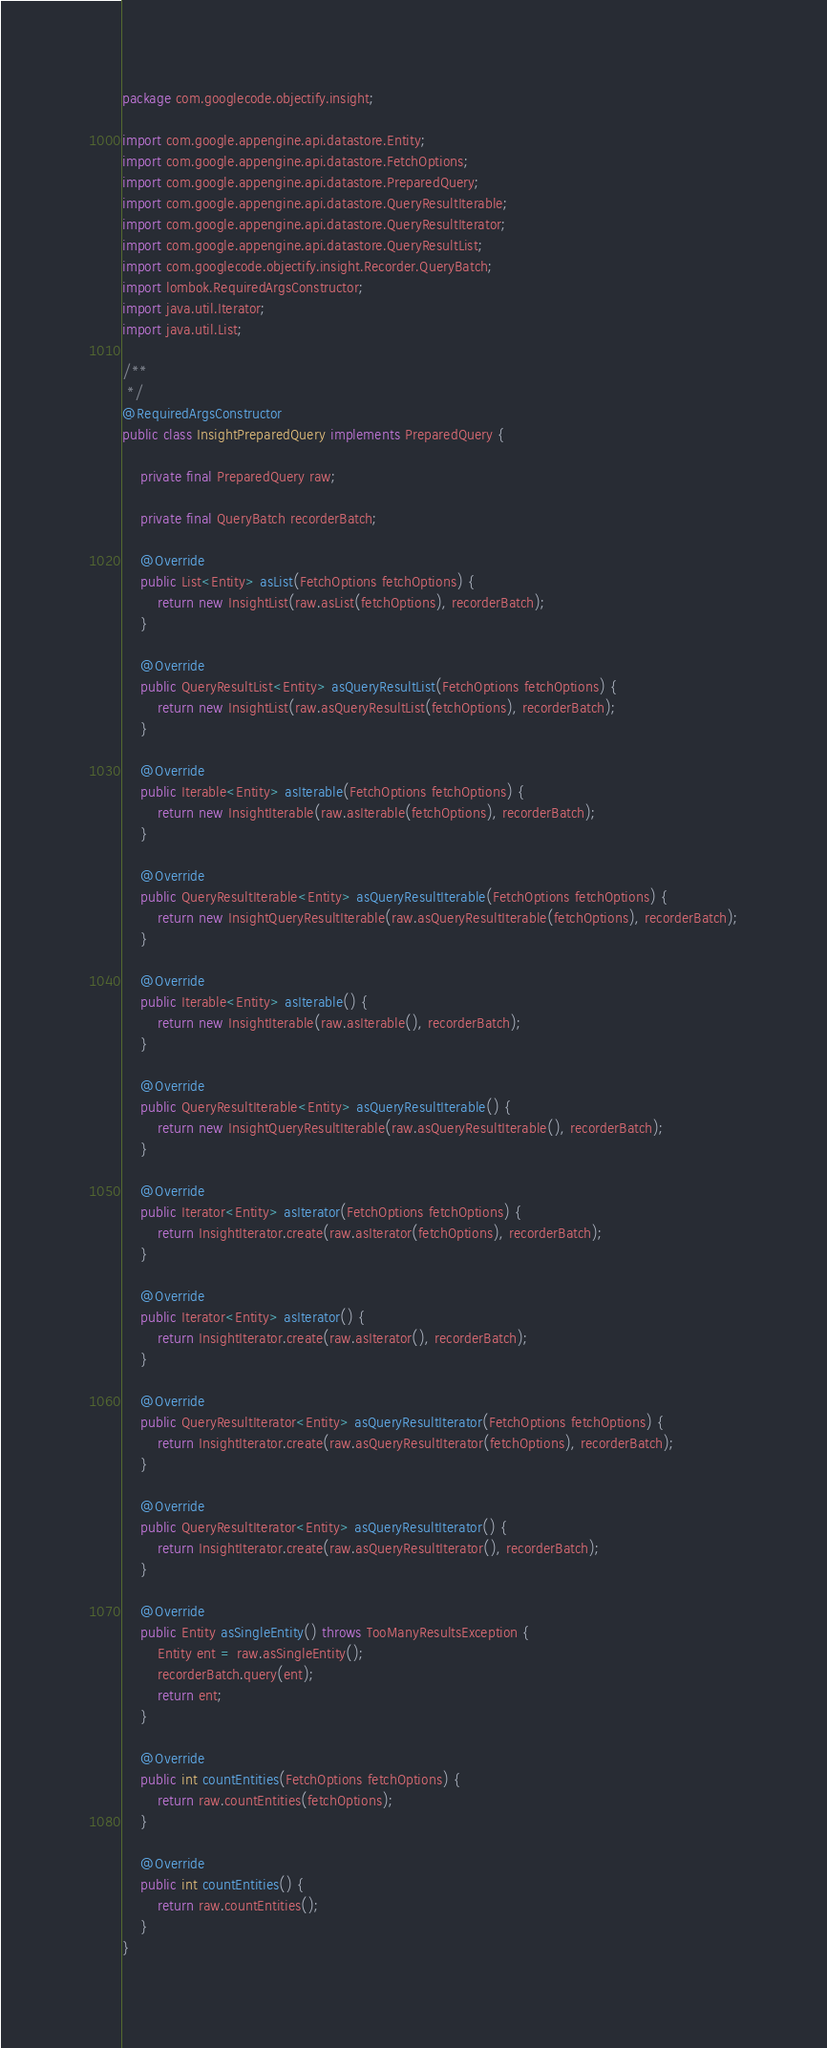<code> <loc_0><loc_0><loc_500><loc_500><_Java_>package com.googlecode.objectify.insight;

import com.google.appengine.api.datastore.Entity;
import com.google.appengine.api.datastore.FetchOptions;
import com.google.appengine.api.datastore.PreparedQuery;
import com.google.appengine.api.datastore.QueryResultIterable;
import com.google.appengine.api.datastore.QueryResultIterator;
import com.google.appengine.api.datastore.QueryResultList;
import com.googlecode.objectify.insight.Recorder.QueryBatch;
import lombok.RequiredArgsConstructor;
import java.util.Iterator;
import java.util.List;

/**
 */
@RequiredArgsConstructor
public class InsightPreparedQuery implements PreparedQuery {

	private final PreparedQuery raw;

	private final QueryBatch recorderBatch;

	@Override
	public List<Entity> asList(FetchOptions fetchOptions) {
		return new InsightList(raw.asList(fetchOptions), recorderBatch);
	}

	@Override
	public QueryResultList<Entity> asQueryResultList(FetchOptions fetchOptions) {
		return new InsightList(raw.asQueryResultList(fetchOptions), recorderBatch);
	}

	@Override
	public Iterable<Entity> asIterable(FetchOptions fetchOptions) {
		return new InsightIterable(raw.asIterable(fetchOptions), recorderBatch);
	}

	@Override
	public QueryResultIterable<Entity> asQueryResultIterable(FetchOptions fetchOptions) {
		return new InsightQueryResultIterable(raw.asQueryResultIterable(fetchOptions), recorderBatch);
	}

	@Override
	public Iterable<Entity> asIterable() {
		return new InsightIterable(raw.asIterable(), recorderBatch);
	}

	@Override
	public QueryResultIterable<Entity> asQueryResultIterable() {
		return new InsightQueryResultIterable(raw.asQueryResultIterable(), recorderBatch);
	}

	@Override
	public Iterator<Entity> asIterator(FetchOptions fetchOptions) {
		return InsightIterator.create(raw.asIterator(fetchOptions), recorderBatch);
	}

	@Override
	public Iterator<Entity> asIterator() {
		return InsightIterator.create(raw.asIterator(), recorderBatch);
	}

	@Override
	public QueryResultIterator<Entity> asQueryResultIterator(FetchOptions fetchOptions) {
		return InsightIterator.create(raw.asQueryResultIterator(fetchOptions), recorderBatch);
	}

	@Override
	public QueryResultIterator<Entity> asQueryResultIterator() {
		return InsightIterator.create(raw.asQueryResultIterator(), recorderBatch);
	}

	@Override
	public Entity asSingleEntity() throws TooManyResultsException {
		Entity ent = raw.asSingleEntity();
		recorderBatch.query(ent);
		return ent;
	}

	@Override
	public int countEntities(FetchOptions fetchOptions) {
		return raw.countEntities(fetchOptions);
	}

	@Override
	public int countEntities() {
		return raw.countEntities();
	}
}
</code> 